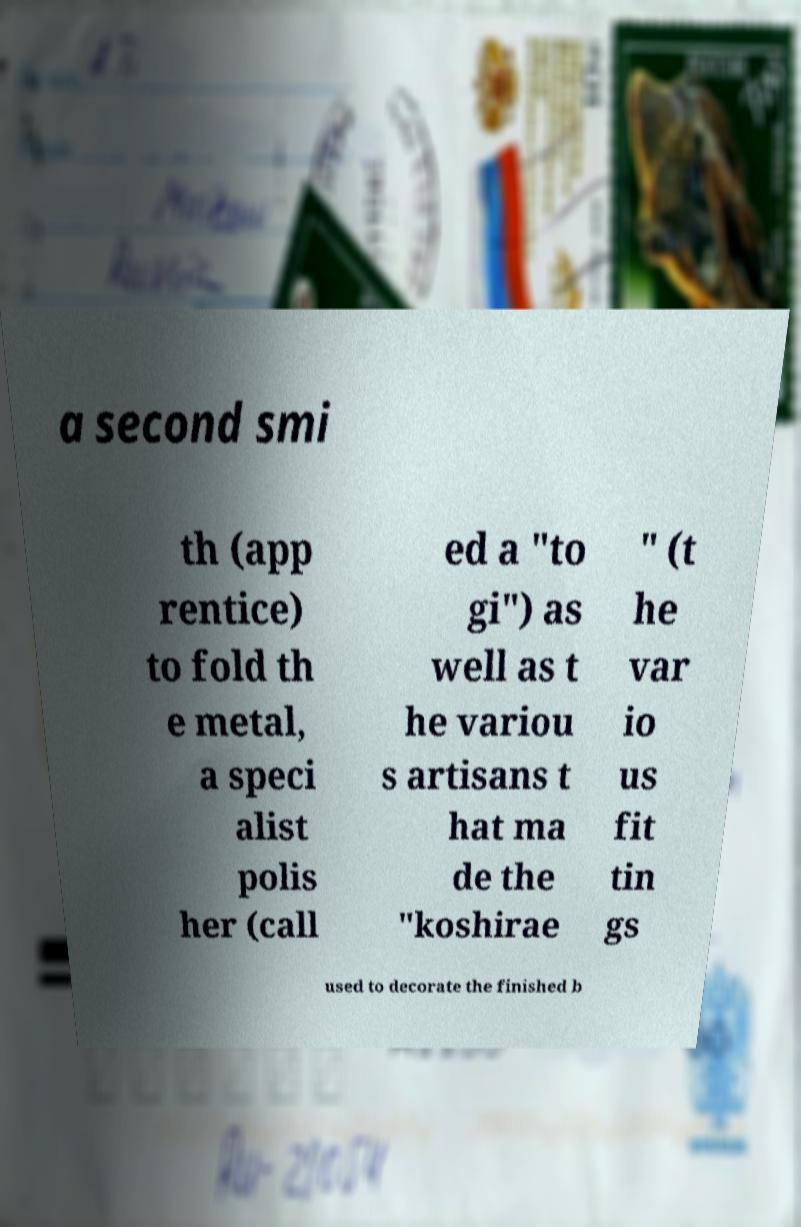For documentation purposes, I need the text within this image transcribed. Could you provide that? a second smi th (app rentice) to fold th e metal, a speci alist polis her (call ed a "to gi") as well as t he variou s artisans t hat ma de the "koshirae " (t he var io us fit tin gs used to decorate the finished b 